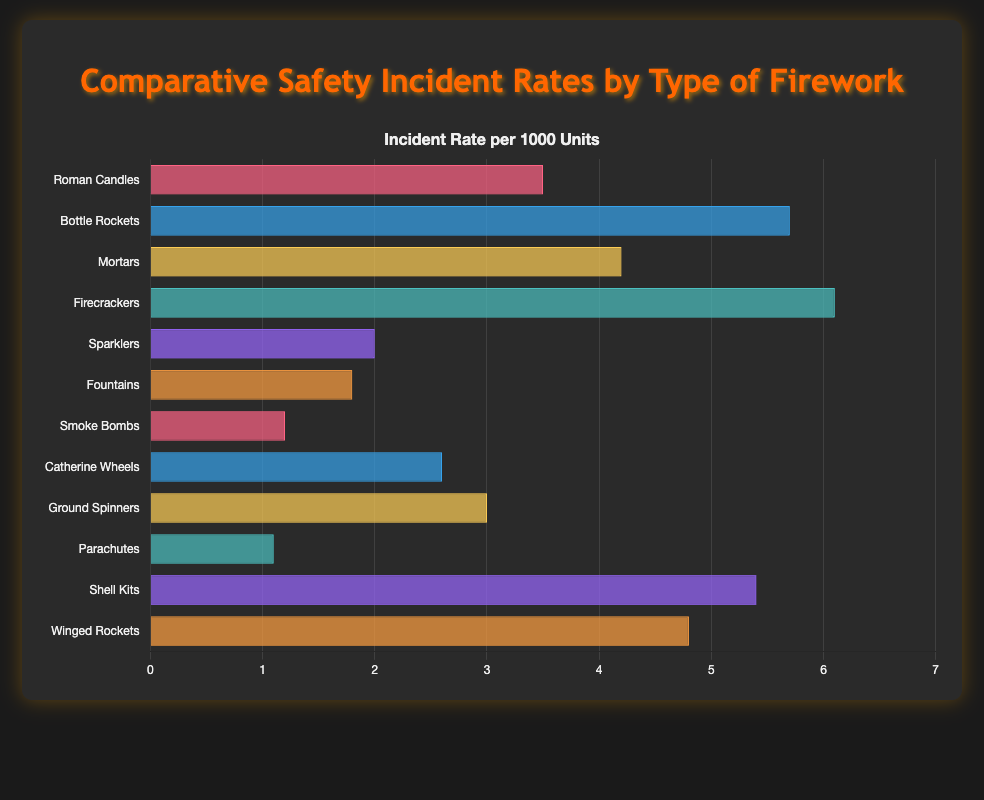What is the incident rate of Firecrackers? The bar representing Firecrackers shows an incident rate of 6.1 per 1000.
Answer: 6.1 Which type of firework has the lowest incident rate? By comparing the lengths of all the bars, Parachutes has the shortest bar with an incident rate of 1.1 per 1000.
Answer: Parachutes How much higher is the incident rate of Bottle Rockets compared to Sparklers? The incident rate of Bottle Rockets is 5.7, while Sparklers is 2.0. The difference is 5.7 - 2.0.
Answer: 3.7 What is the average incident rate of Roman Candles, Mortars, and Firecrackers? The incident rates of Roman Candles, Mortars, and Firecrackers are 3.5, 4.2, and 6.1 respectively. The average is (3.5 + 4.2 + 6.1) / 3.
Answer: 4.6 Which fireworks type has a greater incident rate, Catherine Wheels or Ground Spinners? Catherine Wheels have an incident rate of 2.6, while Ground Spinners have an incident rate of 3.0. So, Ground Spinners have a higher rate.
Answer: Ground Spinners How does the incident rate of Smoke Bombs compare to Shell Kits? The incident rate for Smoke Bombs is 1.2 and for Shell Kits is 5.4. Therefore, Shell Kits have a higher rate.
Answer: Shell Kits What is the difference between the highest and lowest incident rates? The highest incident rate is Firecrackers at 6.1, and the lowest is Parachutes at 1.1. The difference is 6.1 - 1.1.
Answer: 5.0 What is the median incident rate among all firework types? First, list the rates in ascending order: 1.1, 1.2, 1.8, 2.0, 2.6, 3.0, 3.5, 4.2, 4.8, 5.4, 5.7, 6.1. Since there are 12 data points, the median is the average of the 6th and 7th values: (3.0 + 3.5) / 2.
Answer: 3.25 Which type of firework has an incident rate closer to 5 per 1000, Winged Rockets or Mortars? Winged Rockets have an incident rate of 4.8, and Mortars have 4.2. Winged Rockets' incident rate is closer to 5 per 1000.
Answer: Winged Rockets How many firework types have an incident rate above 4 per 1000? The incident rates above 4 per 1000 are Bottle Rockets (5.7), Mortars (4.2), Firecrackers (6.1), Shell Kits (5.4), and Winged Rockets (4.8).
Answer: 5 